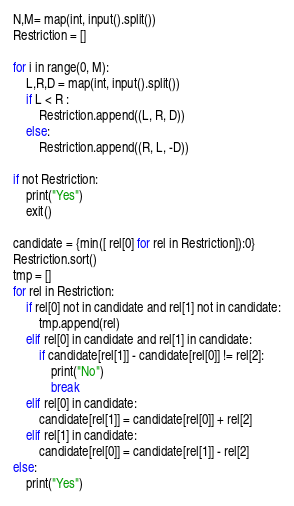Convert code to text. <code><loc_0><loc_0><loc_500><loc_500><_Python_>N,M= map(int, input().split())
Restriction = []

for i in range(0, M):
    L,R,D = map(int, input().split())
    if L < R :
        Restriction.append((L, R, D))
    else:
        Restriction.append((R, L, -D))

if not Restriction:
    print("Yes")
    exit()

candidate = {min([ rel[0] for rel in Restriction]):0}
Restriction.sort()
tmp = []
for rel in Restriction:
    if rel[0] not in candidate and rel[1] not in candidate:
        tmp.append(rel)
    elif rel[0] in candidate and rel[1] in candidate:
        if candidate[rel[1]] - candidate[rel[0]] != rel[2]:
            print("No")
            break
    elif rel[0] in candidate:
        candidate[rel[1]] = candidate[rel[0]] + rel[2]
    elif rel[1] in candidate:
        candidate[rel[0]] = candidate[rel[1]] - rel[2]
else:
    print("Yes")
</code> 